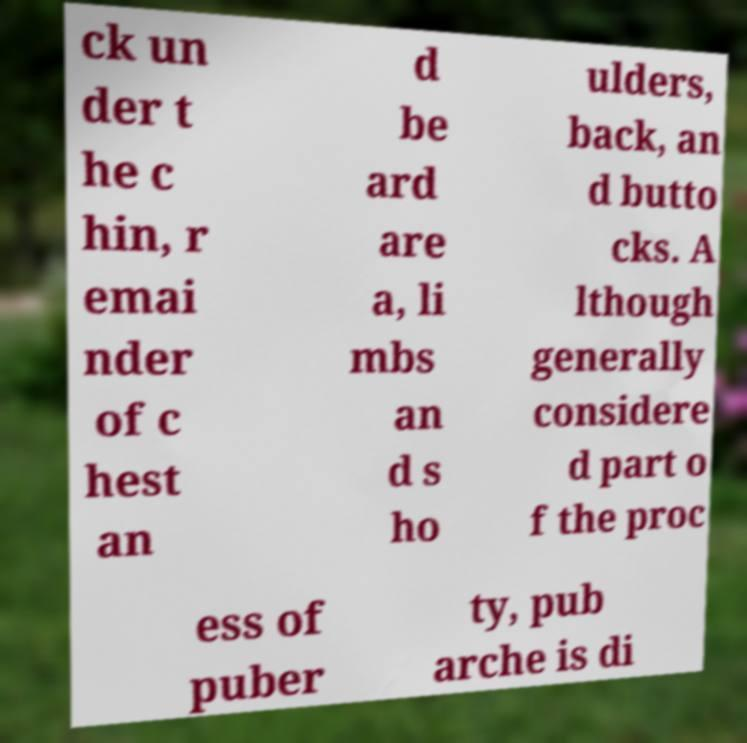Could you assist in decoding the text presented in this image and type it out clearly? ck un der t he c hin, r emai nder of c hest an d be ard are a, li mbs an d s ho ulders, back, an d butto cks. A lthough generally considere d part o f the proc ess of puber ty, pub arche is di 